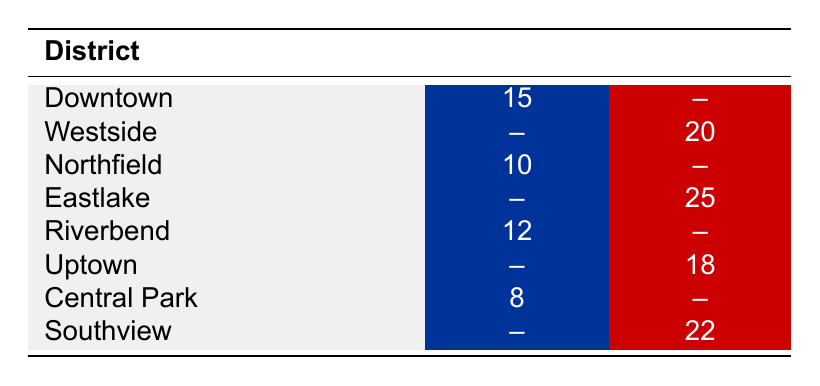What is the total number of campaign events held by the Democratic Party? To find the total number of campaign events held by the Democratic Party, we sum the events from each district where they are listed: Downtown (15) + Northfield (10) + Riverbend (12) + Central Park (8) = 45.
Answer: 45 What is the number of campaign events held by the Republican Party in Eastlake? The table lists the number of events held by the Republican Party in Eastlake as 25.
Answer: 25 How many more campaign events did the Republican Party hold in Southview compared to the Democratic Party in Downtown? The Republican Party held 22 events in Southview, while the Democratic Party held 15 events in Downtown. The difference is 22 - 15 = 7.
Answer: 7 Is it true that the Democratic Party held more events in Riverbend than the Republican Party held in Uptown? The Democratic Party held 12 events in Riverbend, while the Republican Party held 18 events in Uptown. Since 12 is less than 18, the statement is false.
Answer: No What is the average number of campaign events for the Republican Party across all districts they operated in? The Republican Party held events in 4 districts (Westside, Eastlake, Uptown, Southview). The total number of events is 20 + 25 + 18 + 22 = 85. To find the average, we divide 85 by 4, which gives us 21.25.
Answer: 21.25 In which district did the Democratic Party hold the least number of campaign events? The Democratic Party held 8 events in Central Park. This is the lowest among the districts listed for the Democratic Party.
Answer: Central Park What is the total number of campaign events held across all districts? To find the total, we add all the events from both parties: (15 + 20 + 10 + 25 + 12 + 18 + 8 + 22) = 130.
Answer: 130 Did the Democratic Party hold more events than the Republican Party in any district? In the data provided, the Democratic Party held more events than the Republican Party only in Downtown (15 events vs. 0).
Answer: Yes What is the difference between the highest number of events for the Republican Party and the lowest for the Democratic Party? The Republican Party had the highest events in Eastlake with 25. The lowest for the Democratic Party was in Central Park with 8. The difference is 25 - 8 = 17.
Answer: 17 